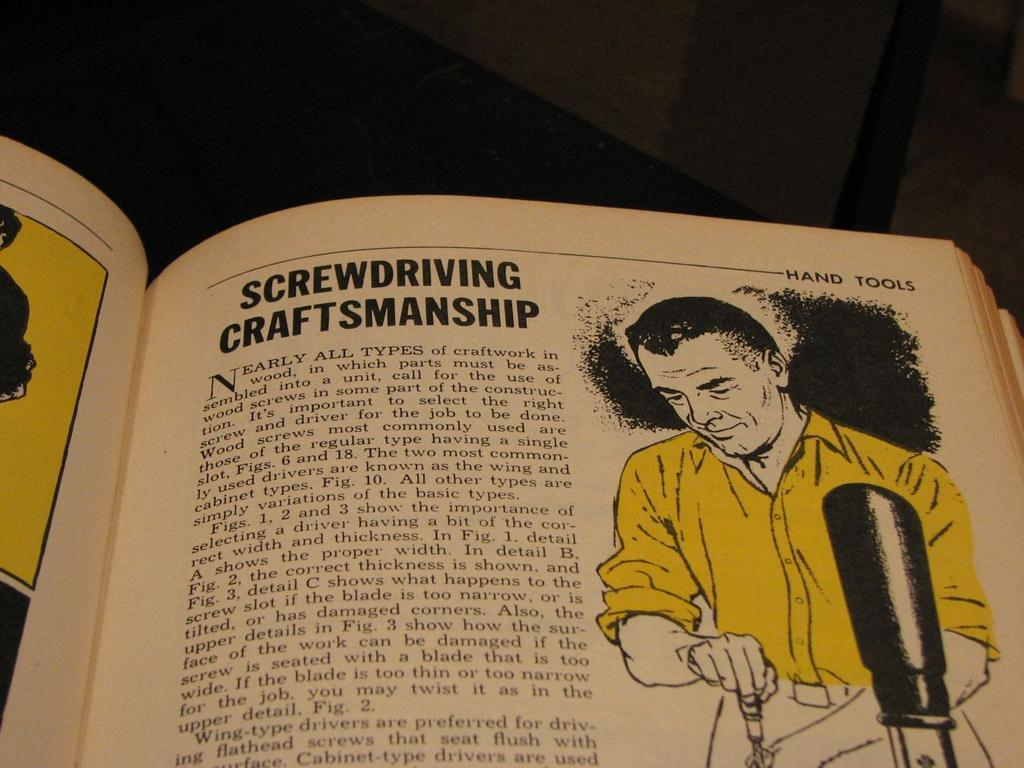<image>
Create a compact narrative representing the image presented. An article in an old book about Screwdriving Craftsmanship. 